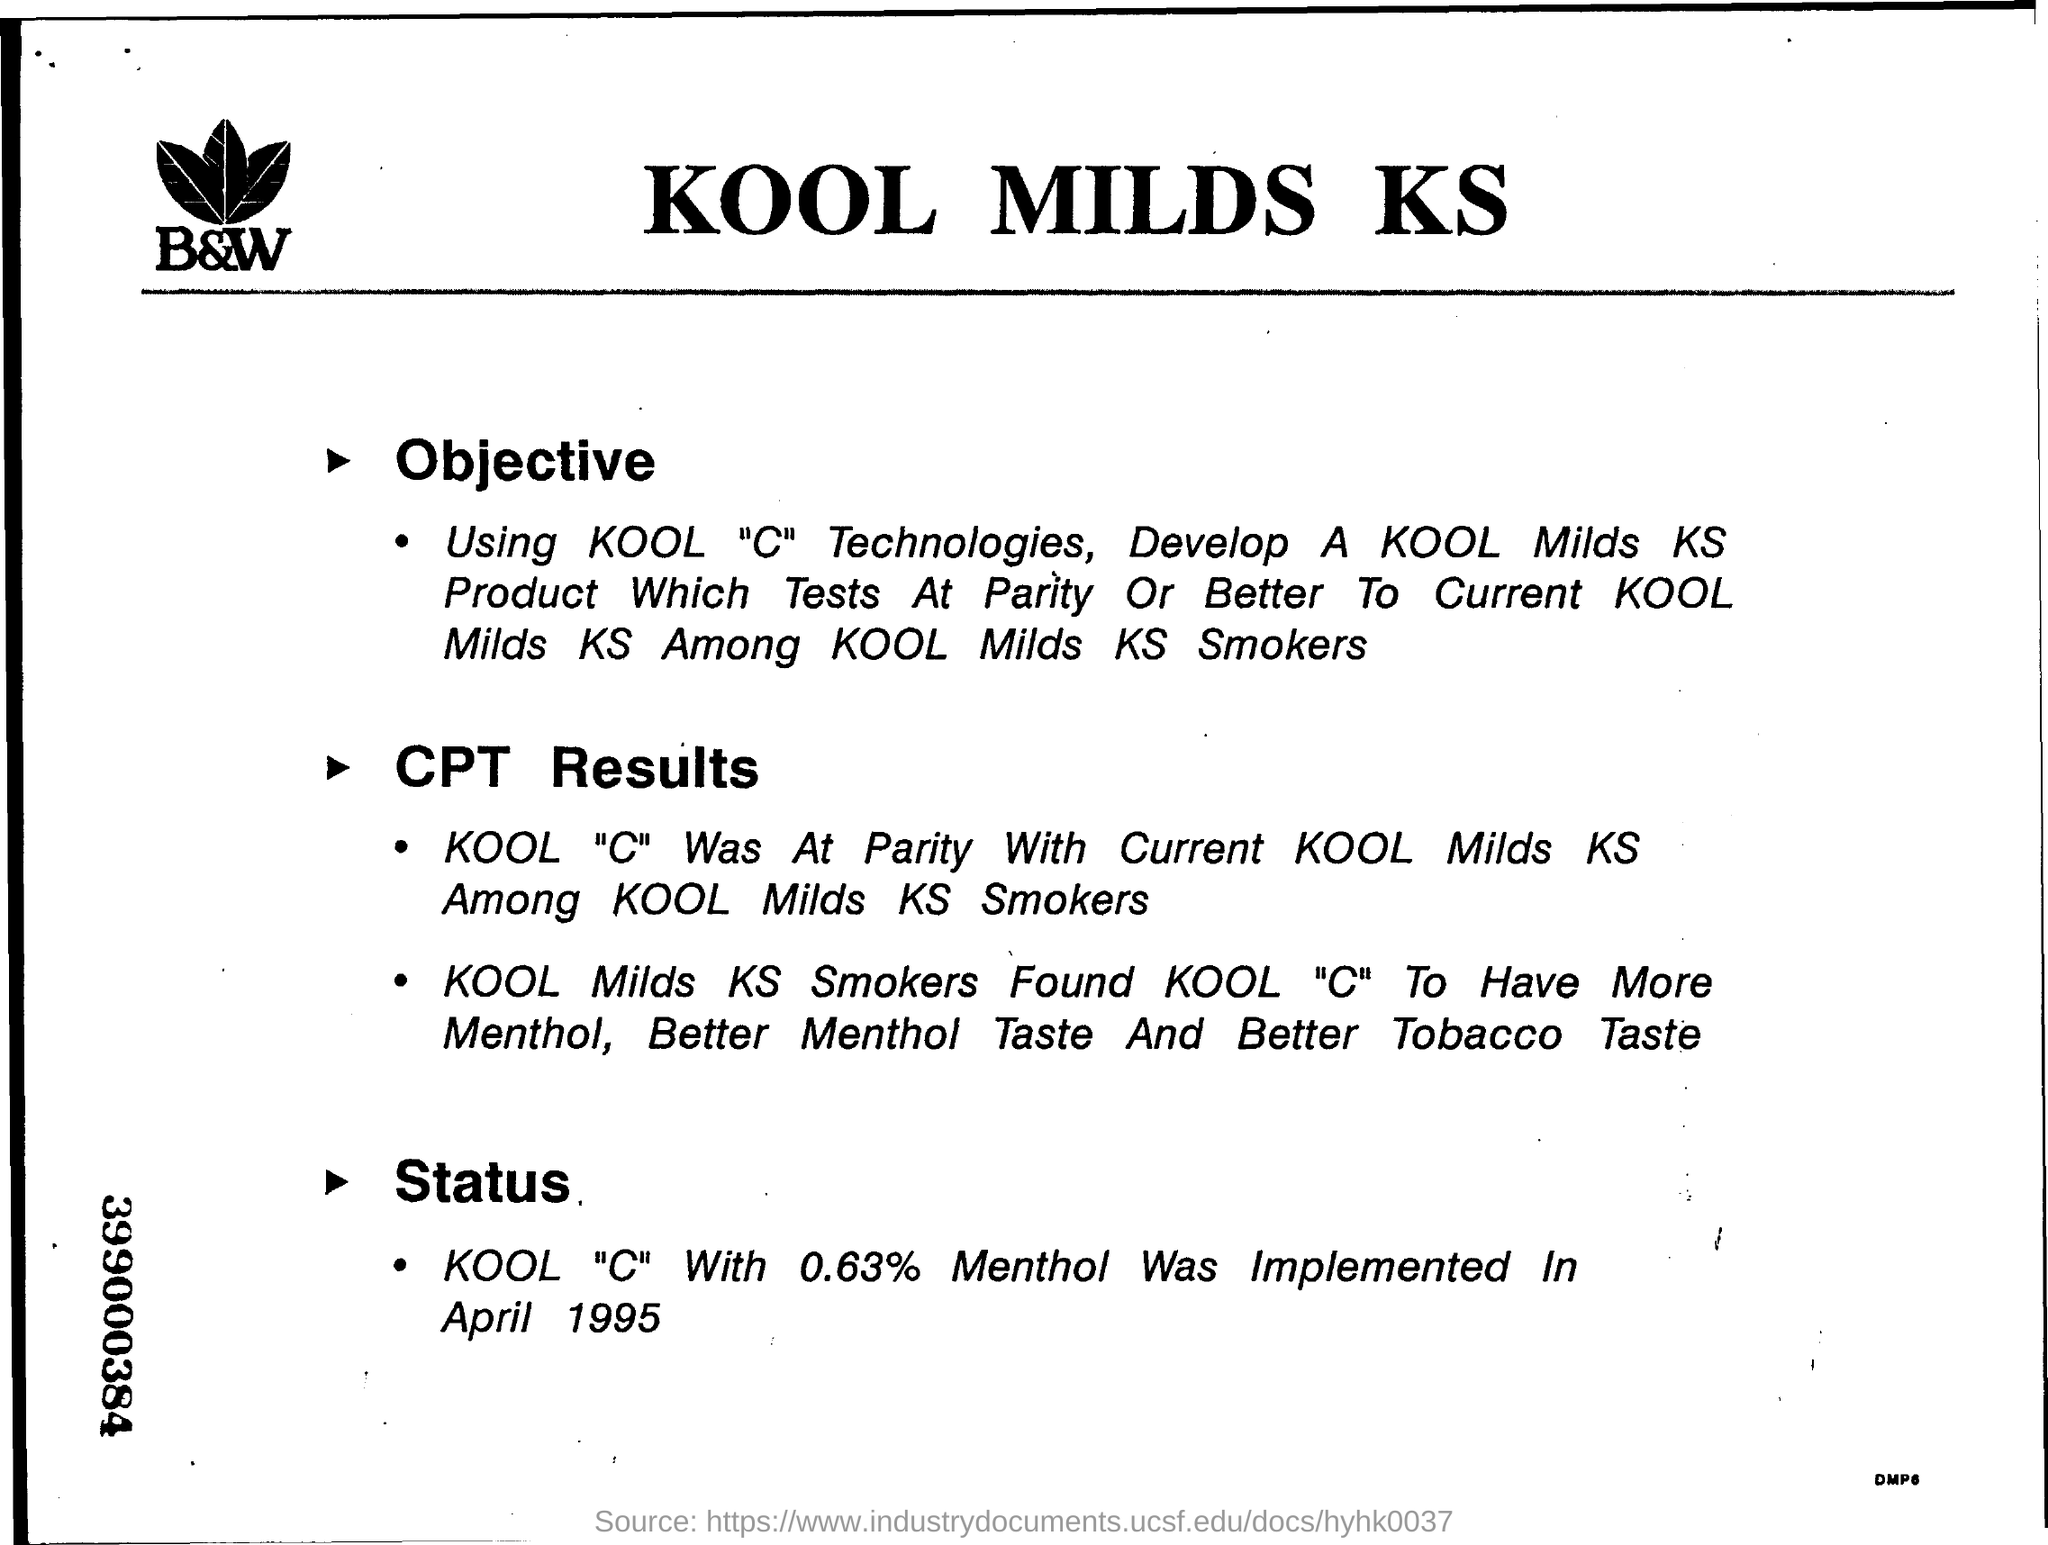What is the status of the KOOL MILDS KS?
Your response must be concise. Kool "C" with 0.63% menthol was implemented in April 1995. What is the objective of the KOOL MILDS KS?
Offer a very short reply. Using Kool "C" Technologies, Develop a Kool Milds KS Product which Tests at Parity or Better to Current Kool Milds KS among Kool Milds KS Smokers. What is the name of the company?
Offer a terse response. Kool Milds KS. When was the KOOL "C" With 0.63% Menthol Implemented?
Offer a very short reply. April 1995. 